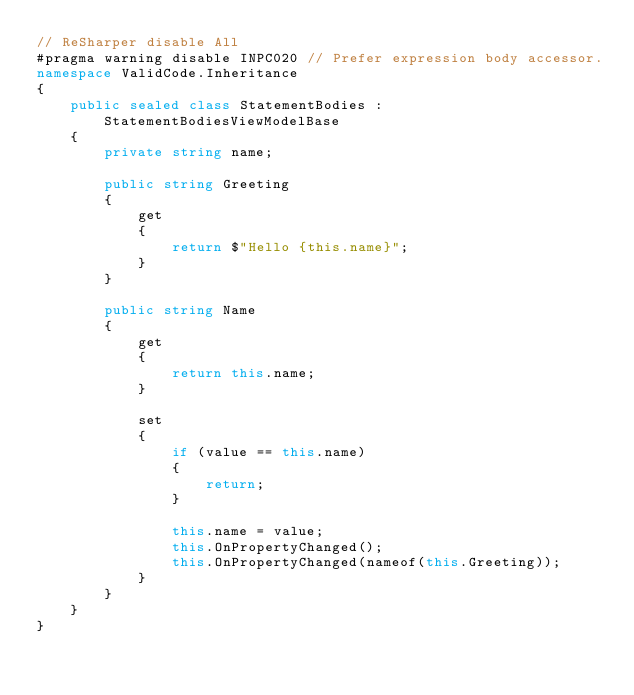Convert code to text. <code><loc_0><loc_0><loc_500><loc_500><_C#_>// ReSharper disable All
#pragma warning disable INPC020 // Prefer expression body accessor.
namespace ValidCode.Inheritance
{
    public sealed class StatementBodies : StatementBodiesViewModelBase
    {
        private string name;

        public string Greeting
        {
            get
            {
                return $"Hello {this.name}";
            }
        }

        public string Name
        {
            get
            {
                return this.name;
            }

            set
            {
                if (value == this.name)
                {
                    return;
                }

                this.name = value;
                this.OnPropertyChanged();
                this.OnPropertyChanged(nameof(this.Greeting));
            }
        }
    }
}
</code> 